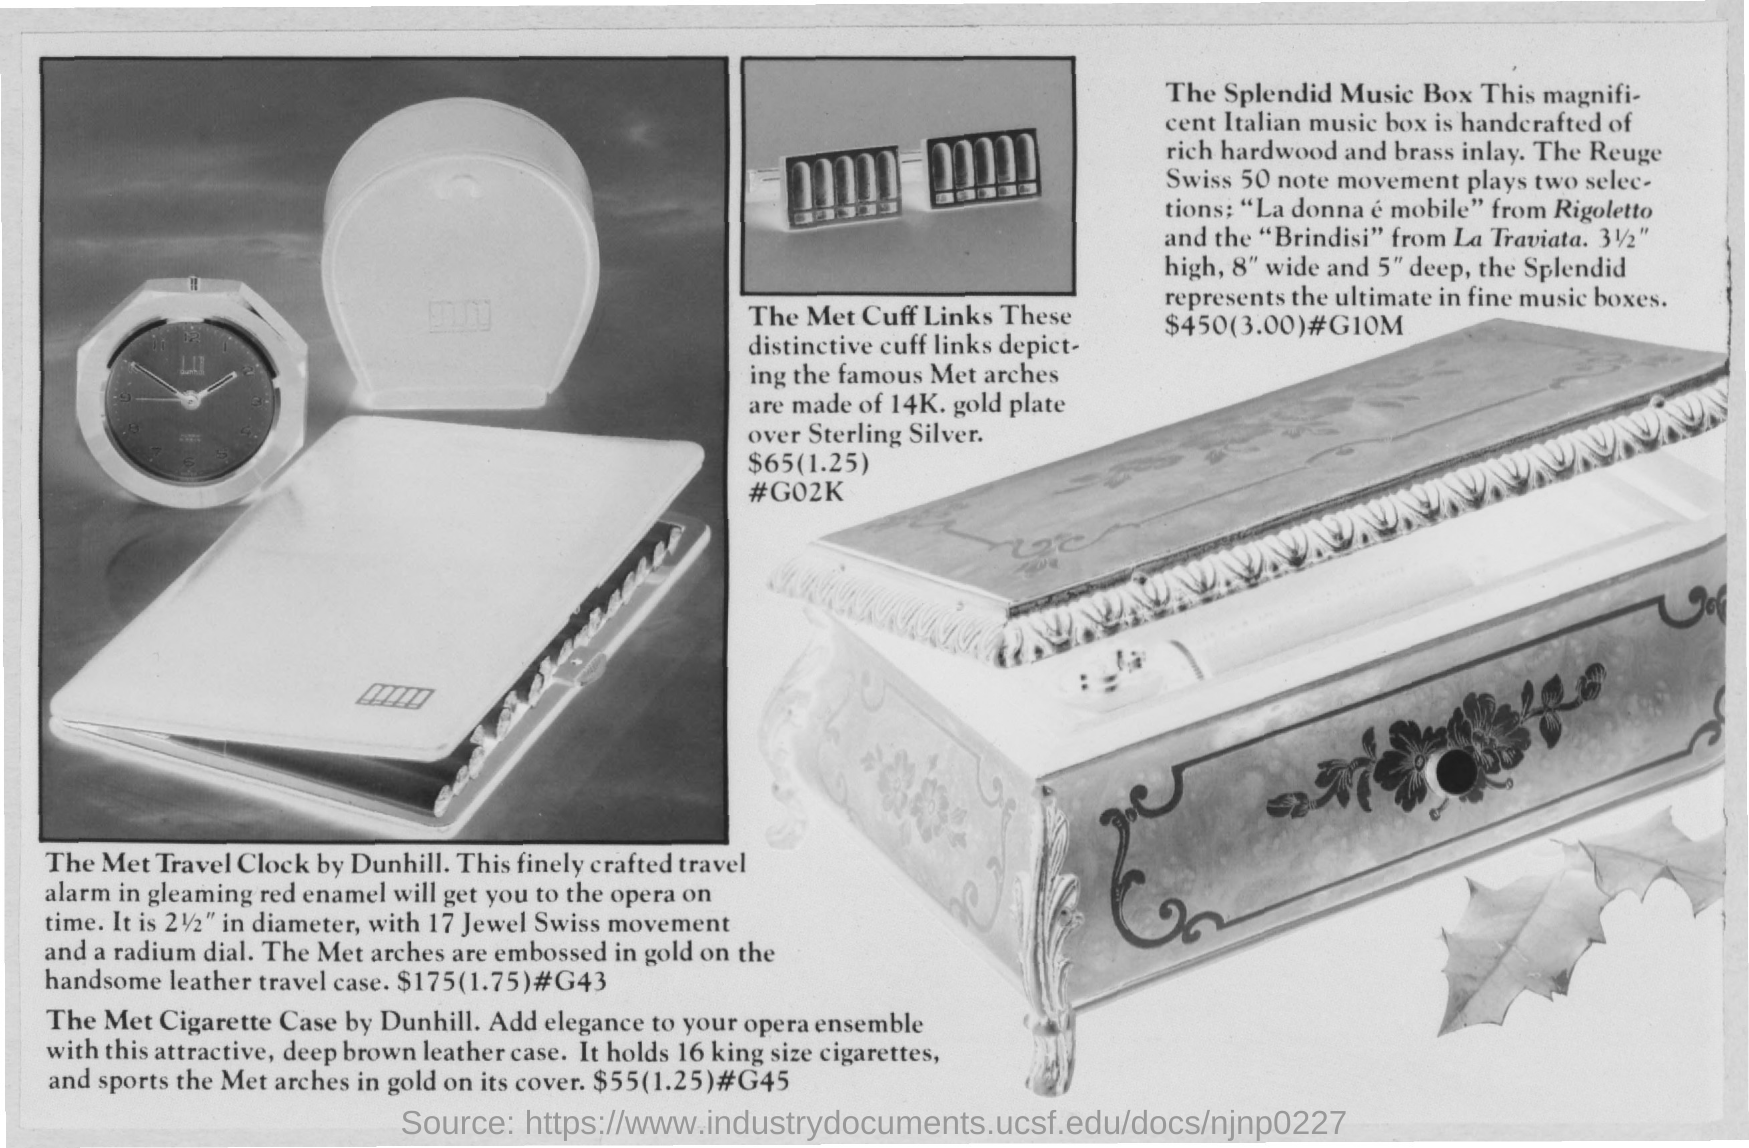Highlight a few significant elements in this photo. The cost of the Travel Clock is $175. 